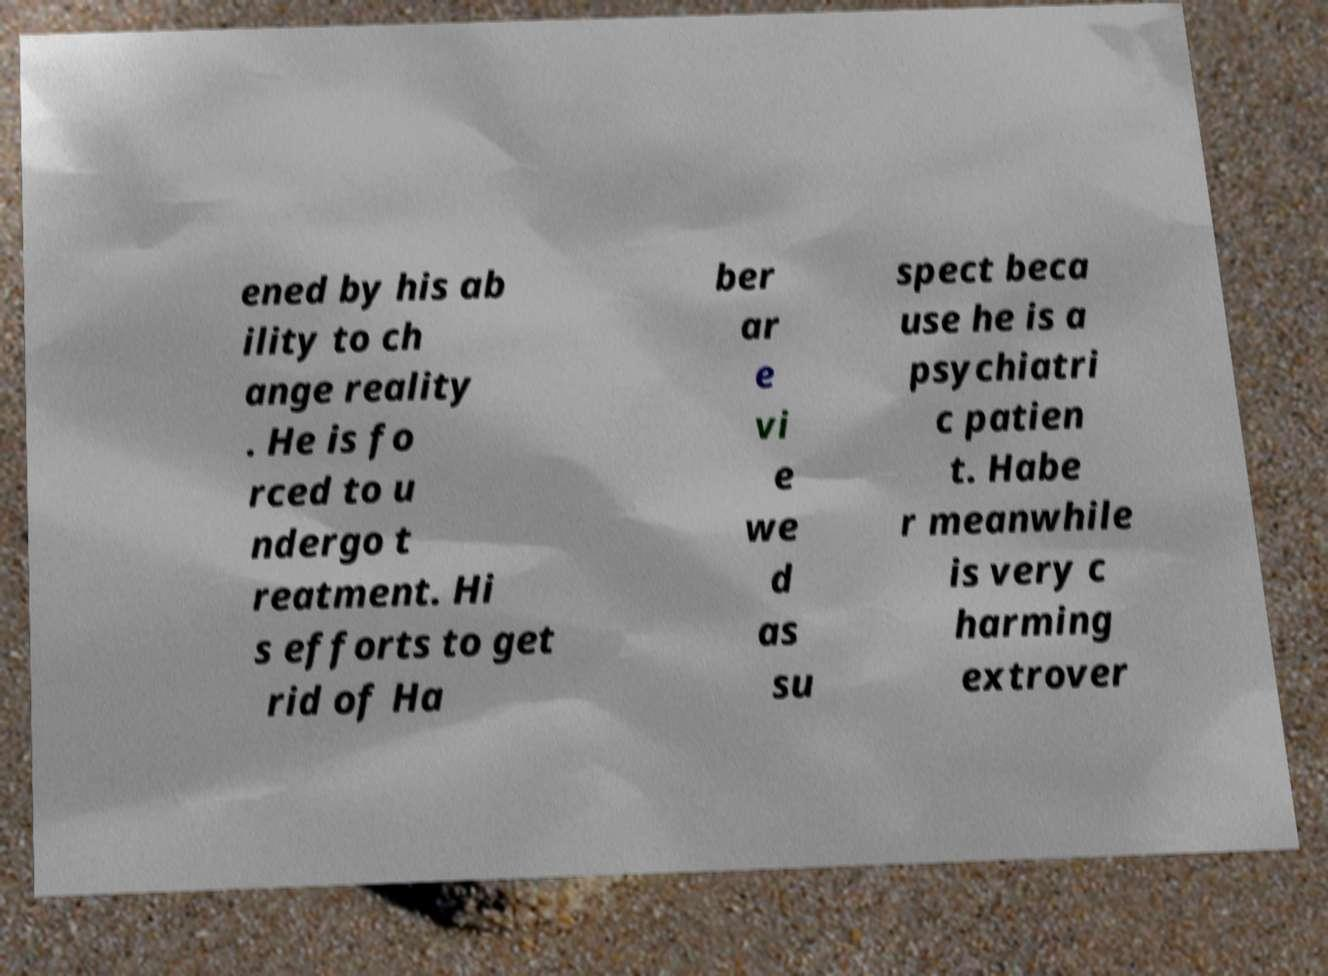What messages or text are displayed in this image? I need them in a readable, typed format. ened by his ab ility to ch ange reality . He is fo rced to u ndergo t reatment. Hi s efforts to get rid of Ha ber ar e vi e we d as su spect beca use he is a psychiatri c patien t. Habe r meanwhile is very c harming extrover 